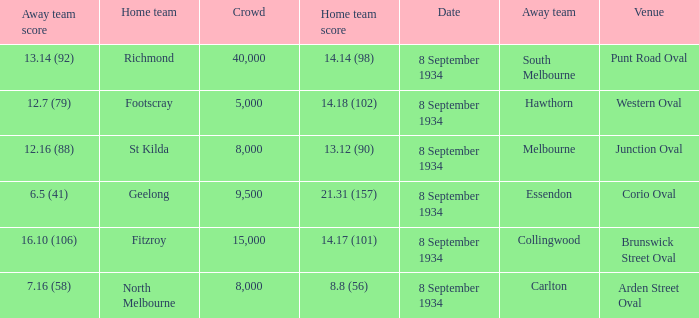When the Venue was Punt Road Oval, who was the Home Team? Richmond. 